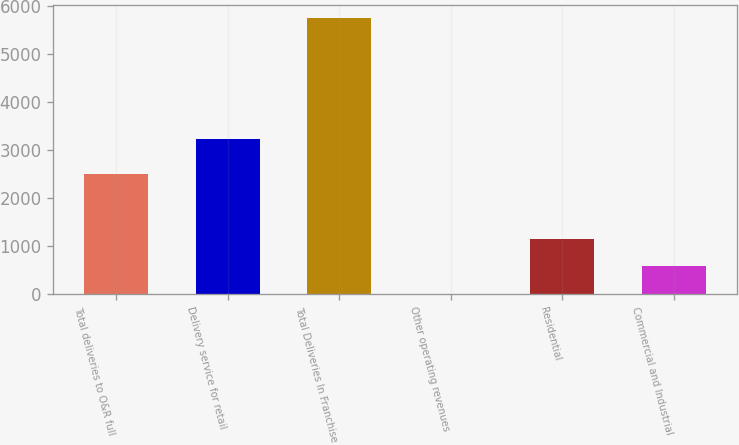Convert chart. <chart><loc_0><loc_0><loc_500><loc_500><bar_chart><fcel>Total deliveries to O&R full<fcel>Delivery service for retail<fcel>Total Deliveries In Franchise<fcel>Other operating revenues<fcel>Residential<fcel>Commercial and Industrial<nl><fcel>2499<fcel>3237<fcel>5736<fcel>9<fcel>1154.4<fcel>581.7<nl></chart> 